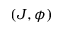Convert formula to latex. <formula><loc_0><loc_0><loc_500><loc_500>( J , \phi )</formula> 